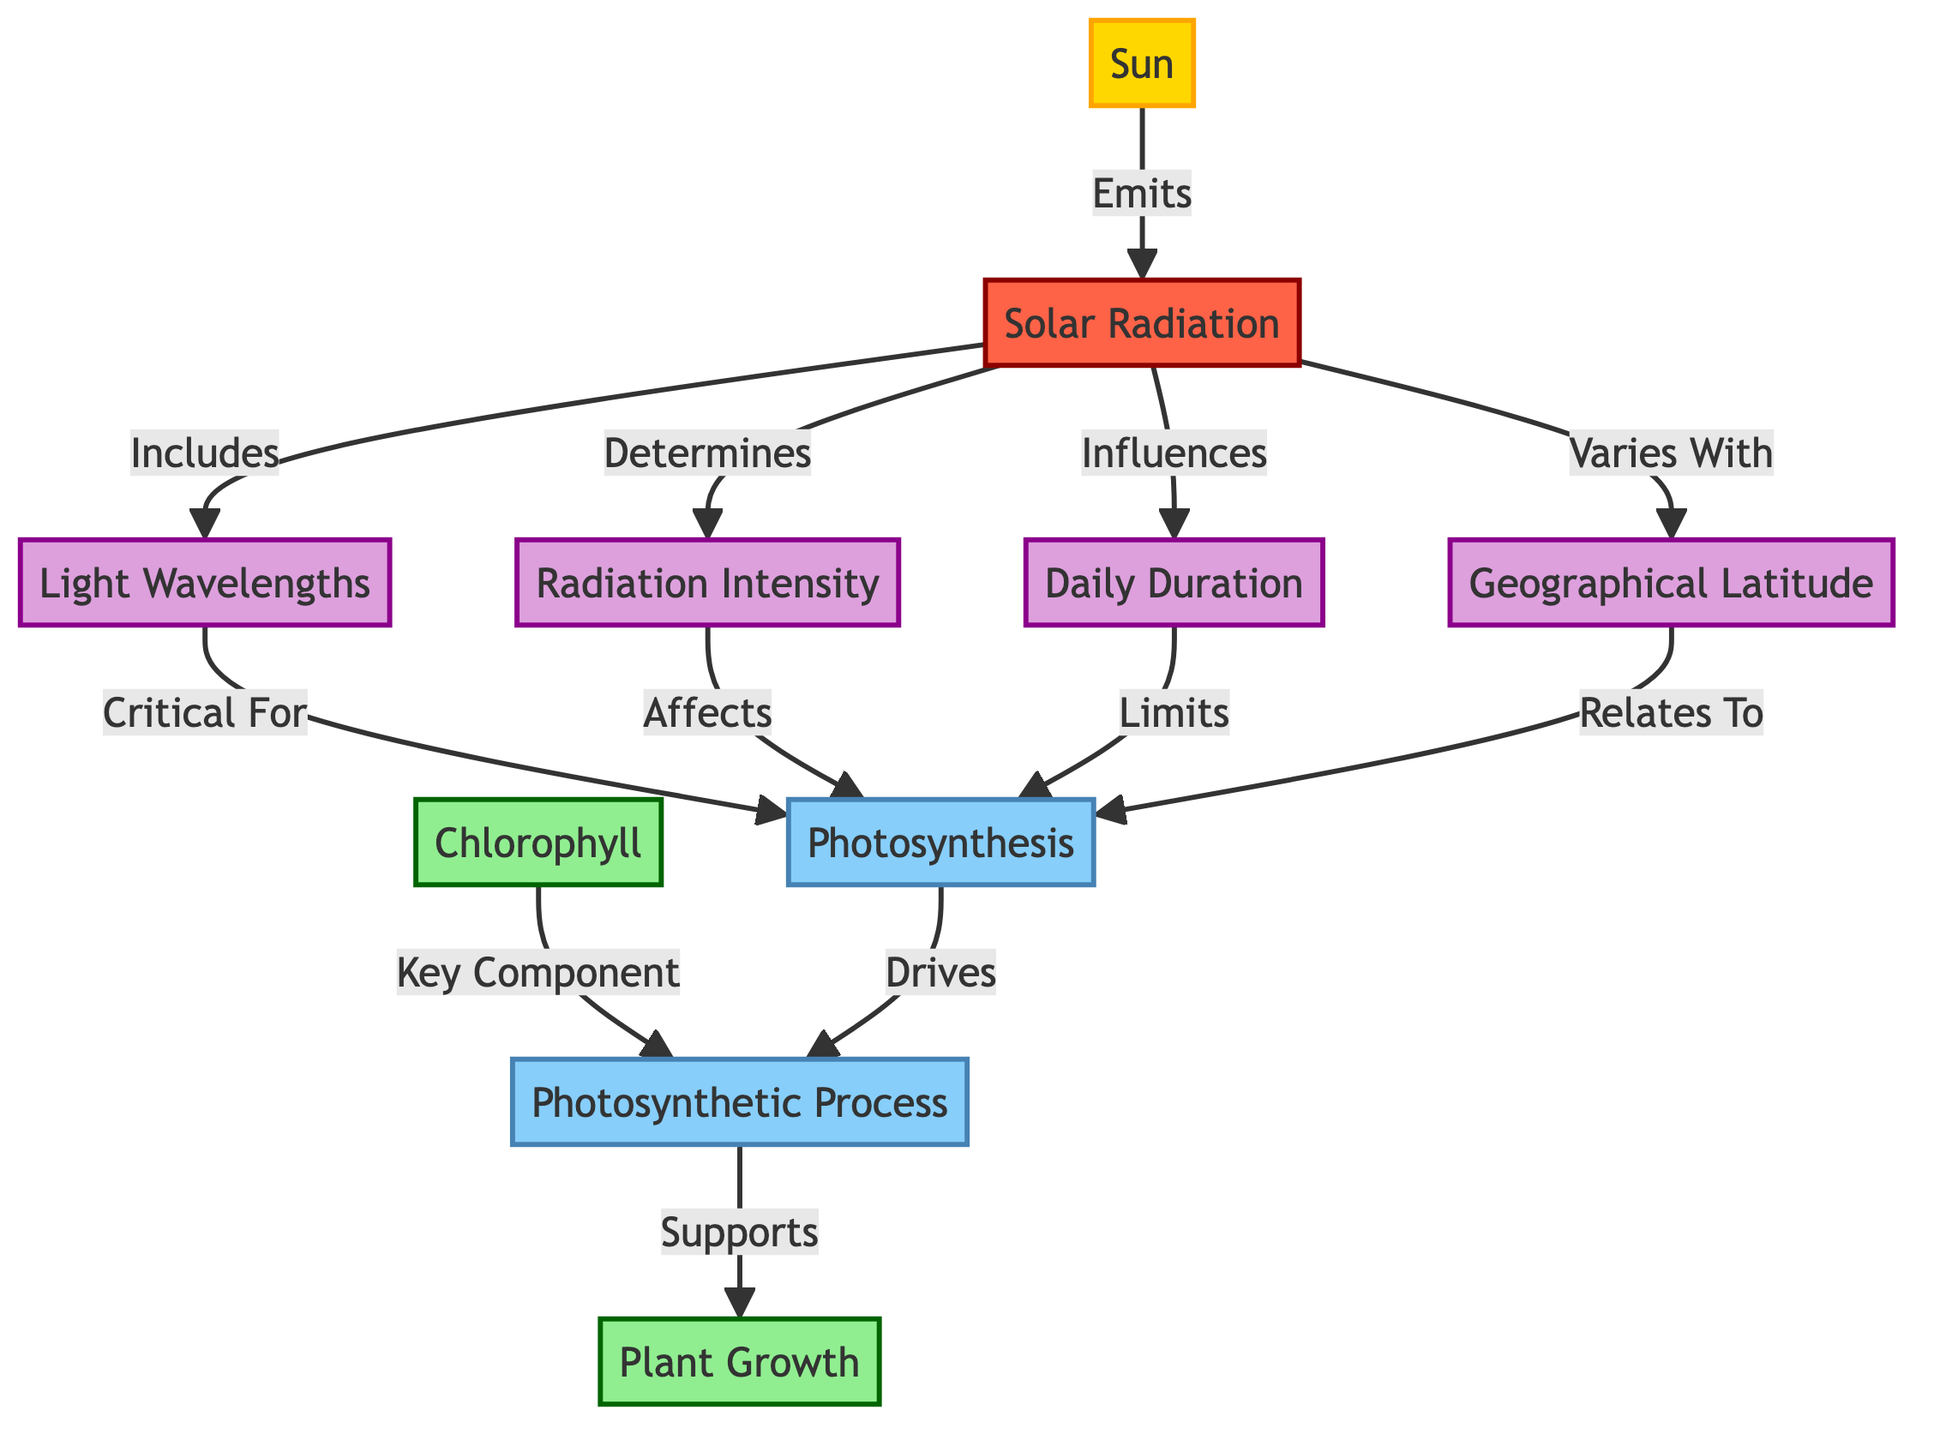What is the primary source of solar radiation? The diagram indicates that the Sun is the primary source of solar radiation, as it shows directional arrows leading from the Sun to solar radiation.
Answer: Sun How many factors influence solar radiation? The diagram clearly lists four factors that influence solar radiation: wavelengths, intensity, duration, and latitude. Therefore, counting these nodes gives us the number four.
Answer: 4 What component is critical for photosynthesis? The diagram points out that wavelengths are indicated as critical for photosynthesis. This can be seen in the direct connection made between wavelengths and photosynthesis.
Answer: Wavelengths What does chlorophyll relate to in the diagram? Chlorophyll is described as a key component of the photosynthetic process, which can be deduced from the connection between chlorophyll and photosynthetic process.
Answer: Photosynthetic process How does intensity affect photosynthesis? The diagram shows that intensity affects photosynthesis directly, which can be determined by the line between intensity and photosynthesis, indicating their relationship.
Answer: Affects What drives the photosynthetic process? According to the diagram, photosynthesis itself drives the photosynthetic process, as indicated by the line flowing from photosynthesis to the photosynthetic process.
Answer: Photosynthesis What influences the duration of solar radiation? The diagram states that duration is influenced by solar radiation, thus establishing a direct connection between solar radiation and duration.
Answer: Solar radiation Which process supports plant growth? The diagram establishes that the photosynthetic process supports plant growth, as indicated by the directional line leading from photosynthetic process to plant growth.
Answer: Photosynthetic process 